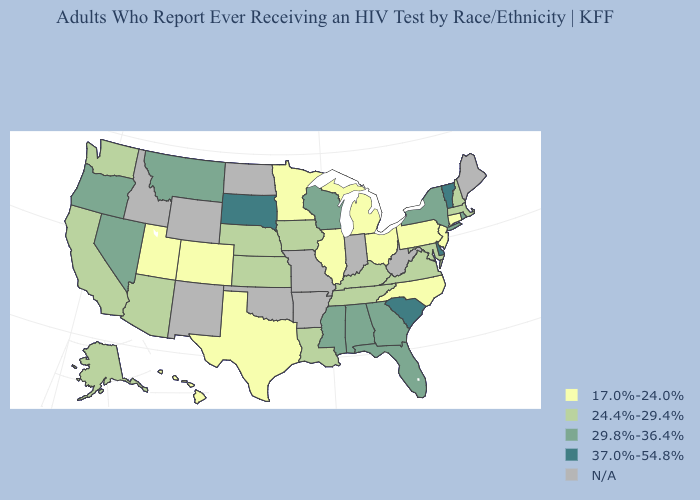Name the states that have a value in the range 24.4%-29.4%?
Keep it brief. Alaska, Arizona, California, Iowa, Kansas, Kentucky, Louisiana, Maryland, Massachusetts, Nebraska, New Hampshire, Tennessee, Virginia, Washington. What is the lowest value in the USA?
Keep it brief. 17.0%-24.0%. Among the states that border Missouri , which have the highest value?
Quick response, please. Iowa, Kansas, Kentucky, Nebraska, Tennessee. Name the states that have a value in the range 29.8%-36.4%?
Give a very brief answer. Alabama, Florida, Georgia, Mississippi, Montana, Nevada, New York, Oregon, Rhode Island, Wisconsin. Among the states that border Idaho , does Utah have the lowest value?
Give a very brief answer. Yes. What is the lowest value in states that border Arkansas?
Answer briefly. 17.0%-24.0%. What is the value of Wyoming?
Answer briefly. N/A. Among the states that border Oregon , does Nevada have the highest value?
Concise answer only. Yes. Which states have the highest value in the USA?
Quick response, please. Delaware, South Carolina, South Dakota, Vermont. What is the highest value in the USA?
Quick response, please. 37.0%-54.8%. Name the states that have a value in the range 24.4%-29.4%?
Quick response, please. Alaska, Arizona, California, Iowa, Kansas, Kentucky, Louisiana, Maryland, Massachusetts, Nebraska, New Hampshire, Tennessee, Virginia, Washington. 